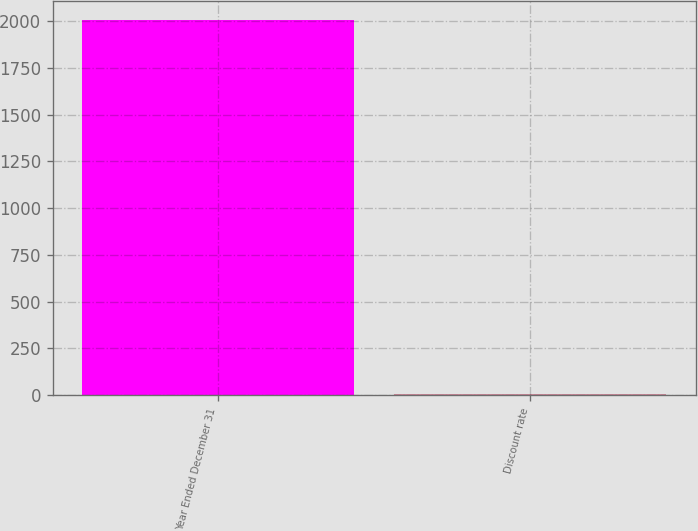<chart> <loc_0><loc_0><loc_500><loc_500><bar_chart><fcel>Year Ended December 31<fcel>Discount rate<nl><fcel>2008<fcel>6<nl></chart> 